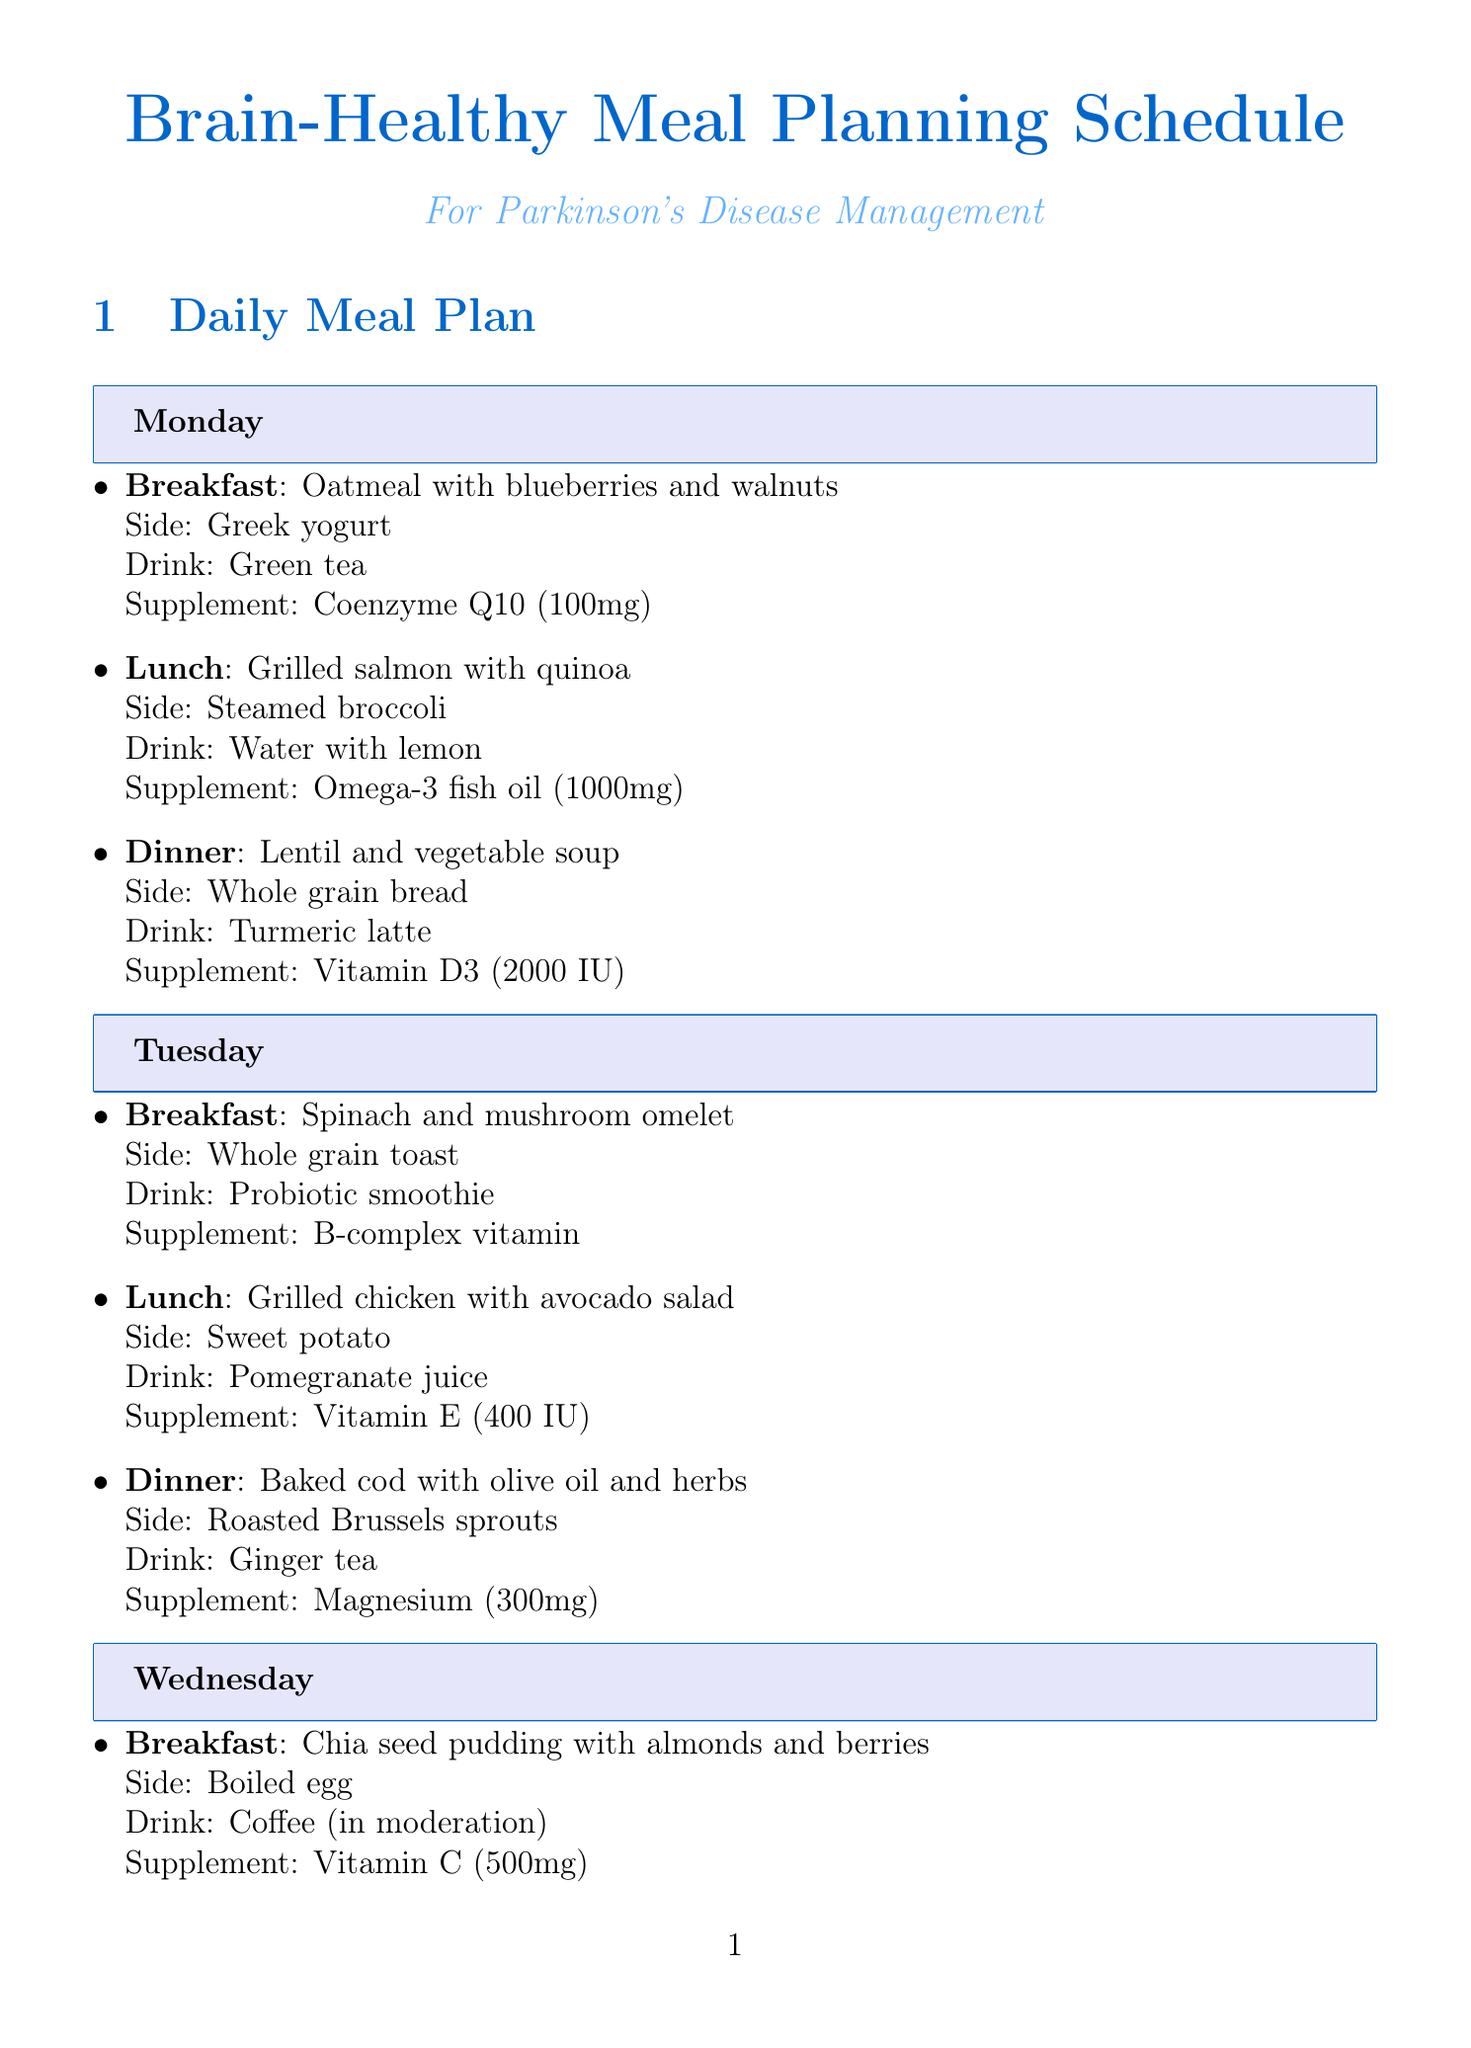What is the main dish for breakfast on Monday? The main dish for breakfast on Monday is Oatmeal with blueberries and walnuts.
Answer: Oatmeal with blueberries and walnuts How many servings of fatty fish should be consumed weekly? The document states that at least 3 servings of fatty fish (salmon, mackerel, sardines) should be consumed weekly.
Answer: 3 servings What supplement is taken with lunch on Wednesday? The supplement taken with lunch on Wednesday is Zinc (15mg).
Answer: Zinc (15mg) Which vegetable is recommended for side on Tuesday's dinner? The side for Tuesday's dinner is Roasted Brussels sprouts.
Answer: Roasted Brussels sprouts What drink is suggested for Monday's dinner? The drink suggested for Monday's dinner is Turmeric latte.
Answer: Turmeric latte What is one of the Parkinson's-specific recommendations mentioned? One of the Parkinson's-specific recommendations is to consult with a dietitian for personalized advice.
Answer: Consult with a dietitian What type of diet is recommended to consider? The document suggests considering a Mediterranean-style diet.
Answer: Mediterranean-style diet What is the drink option for breakfast on Tuesday? The drink option for breakfast on Tuesday is Probiotic smoothie.
Answer: Probiotic smoothie What is the total amount of Vitamin D3 suggested for Monday's dinner? The total amount of Vitamin D3 suggested for Monday's dinner is 2000 IU.
Answer: 2000 IU 